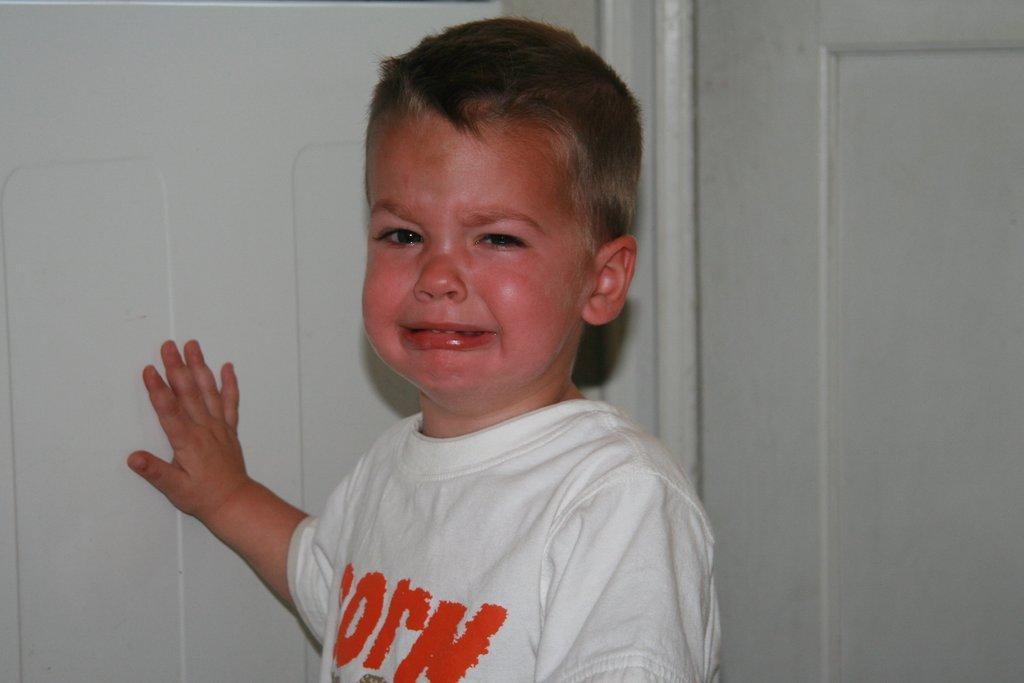Can you describe this image briefly? In this image, we can see a boy crying and in the background, there is a wall. 